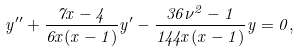<formula> <loc_0><loc_0><loc_500><loc_500>y ^ { \prime \prime } + \frac { 7 x - 4 } { 6 x ( x - 1 ) } y ^ { \prime } - \frac { 3 6 \nu ^ { 2 } - 1 } { 1 4 4 x ( x - 1 ) } y = 0 ,</formula> 